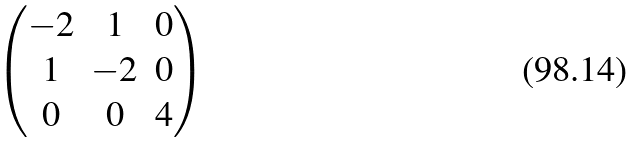Convert formula to latex. <formula><loc_0><loc_0><loc_500><loc_500>\begin{pmatrix} - 2 & 1 & 0 \\ 1 & - 2 & 0 \\ 0 & 0 & 4 \end{pmatrix}</formula> 